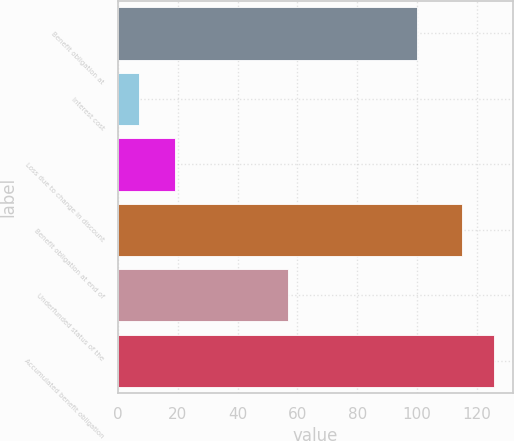<chart> <loc_0><loc_0><loc_500><loc_500><bar_chart><fcel>Benefit obligation at<fcel>Interest cost<fcel>Loss due to change in discount<fcel>Benefit obligation at end of<fcel>Underfunded status of the<fcel>Accumulated benefit obligation<nl><fcel>100<fcel>7<fcel>19<fcel>115<fcel>57<fcel>125.8<nl></chart> 